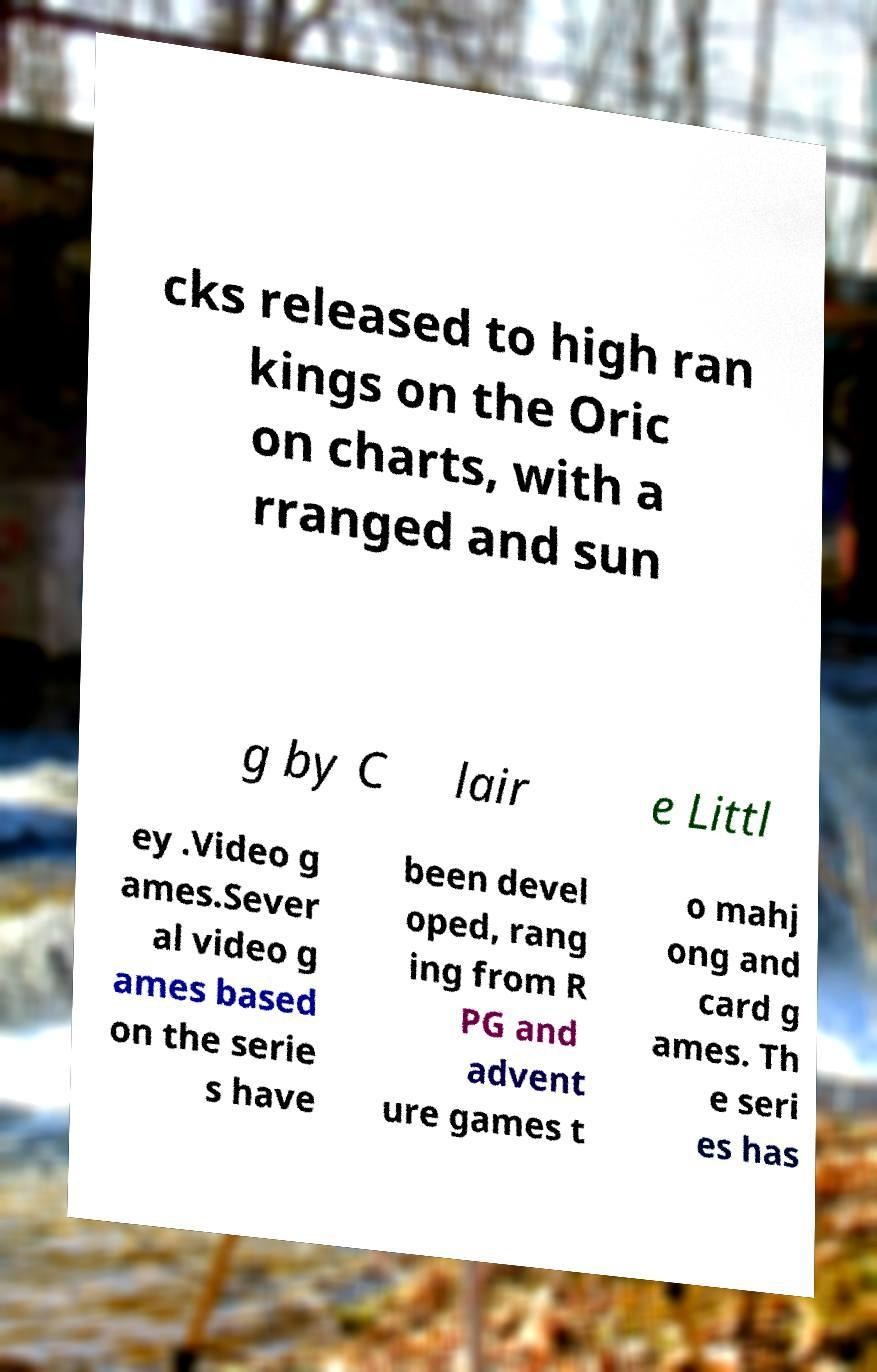What messages or text are displayed in this image? I need them in a readable, typed format. cks released to high ran kings on the Oric on charts, with a rranged and sun g by C lair e Littl ey .Video g ames.Sever al video g ames based on the serie s have been devel oped, rang ing from R PG and advent ure games t o mahj ong and card g ames. Th e seri es has 